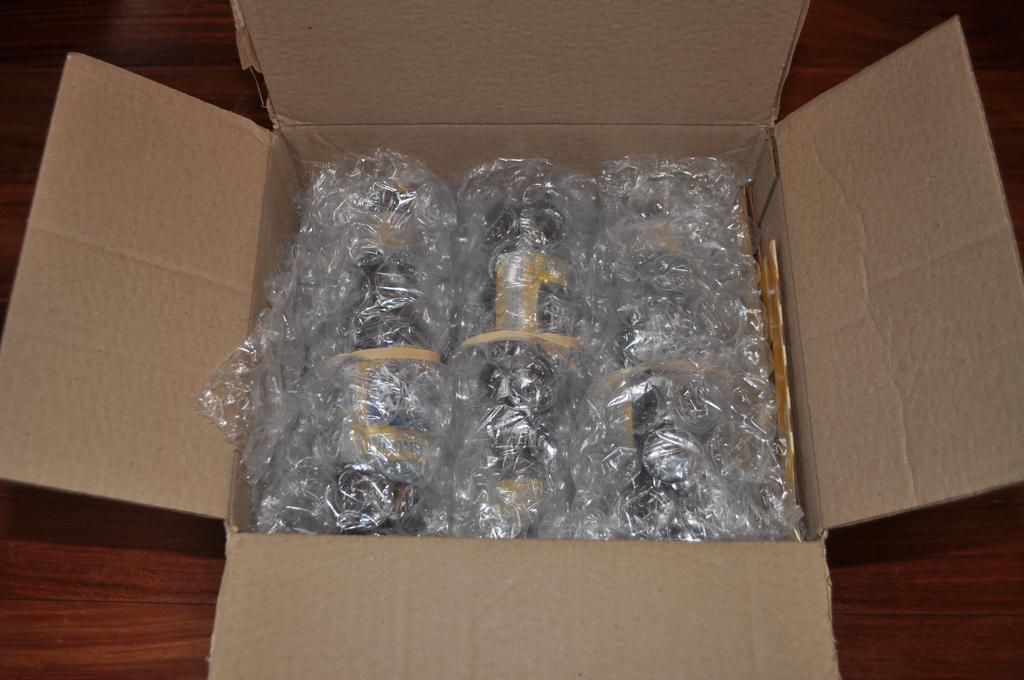What type of material is the plank in the image made of? The wooden plank in the image is made of wood. What is the condition of the cardboard box in the image? The cardboard box in the image is opened. What can be found inside the cardboard box? There are items placed inside the cardboard box, and some of them are covered with polythene. What time does the clock show in the image? There is no clock present in the image. How does the competition affect the items inside the cardboard box? There is no competition present in the image, so it cannot affect the items inside the cardboard box. 